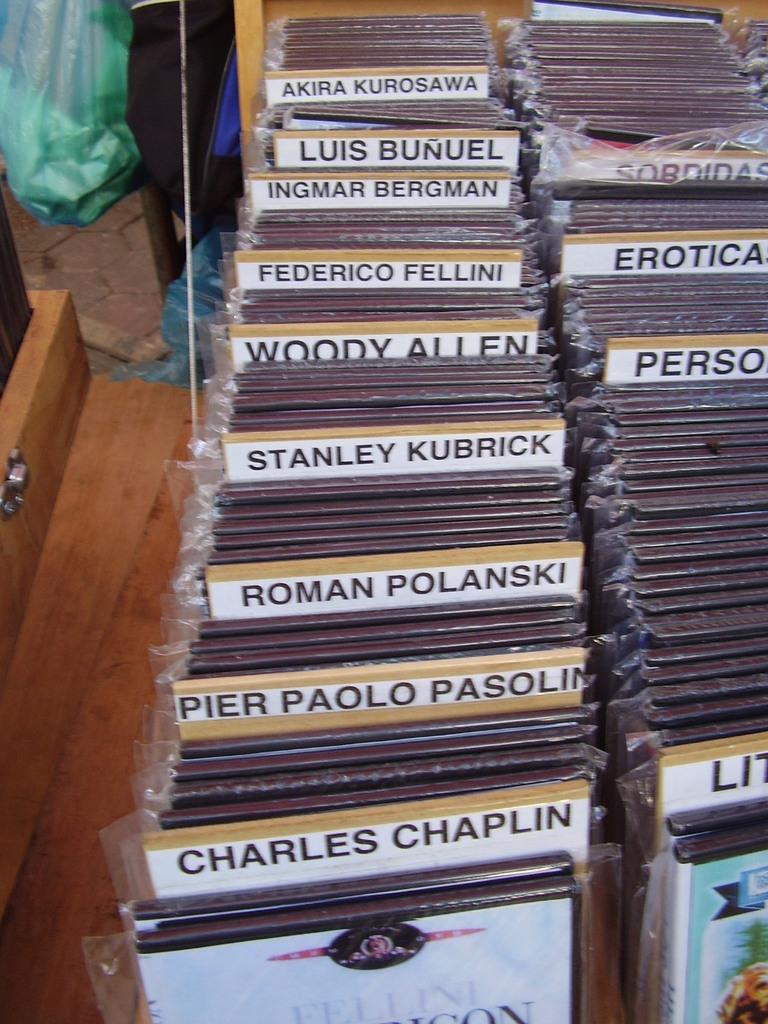Whose name begins with a w?
Provide a short and direct response. Woody allen. 